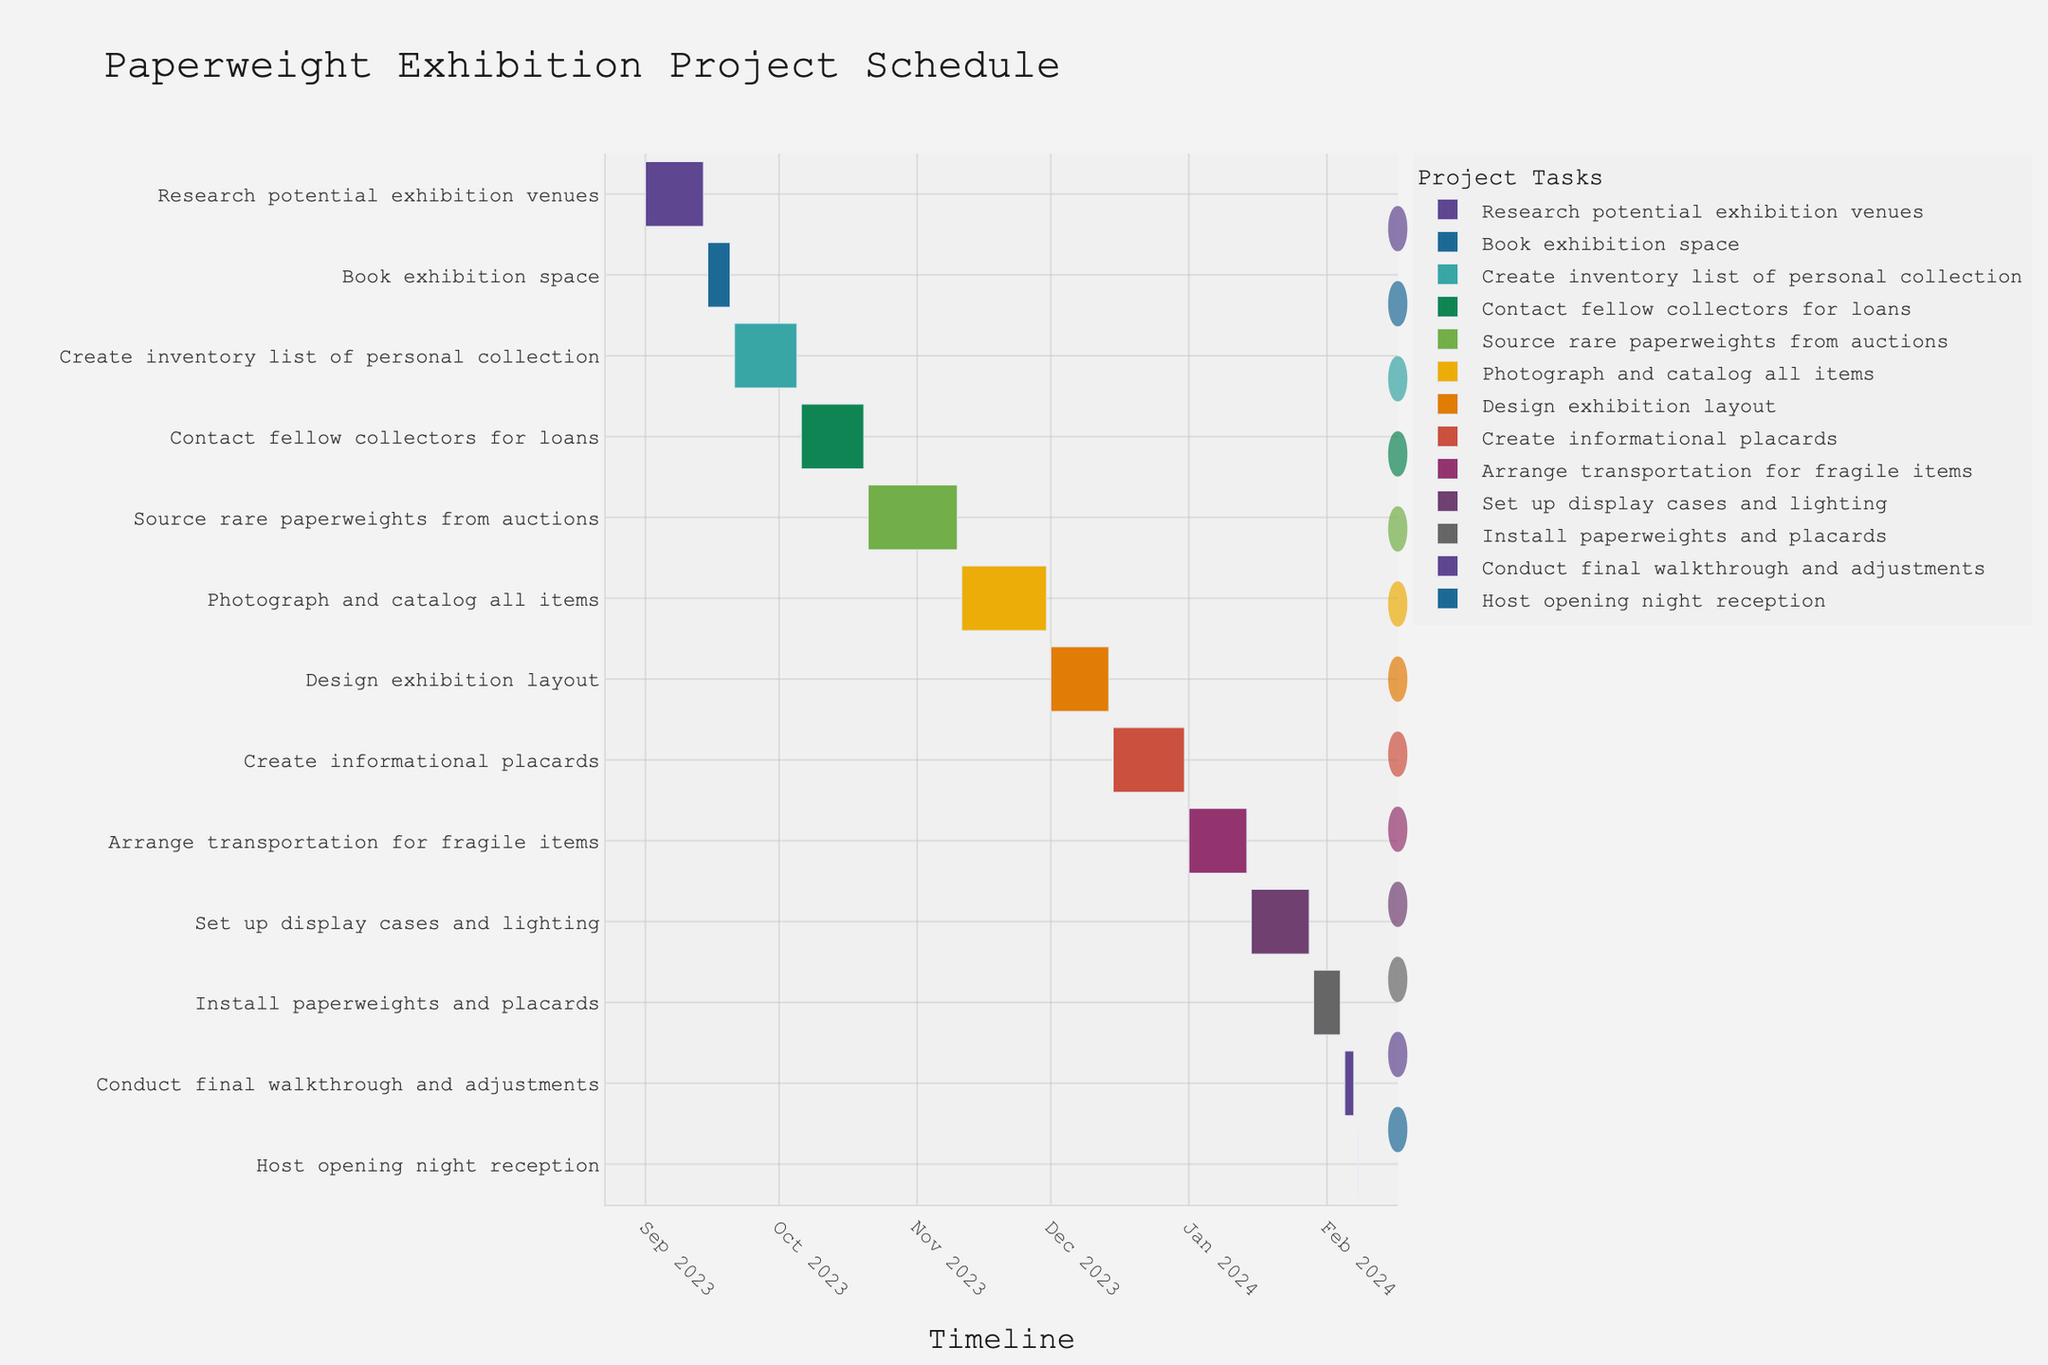What is the title of the Gantt chart? The title of the Gantt chart is visible at the top of the figure.
Answer: Paperweight Exhibition Project Schedule On which date does the task 'Set up display cases and lighting' start? The Gantt chart shows the start and end dates for each task on the timeline.
Answer: January 15, 2024 How many days are allocated for the task 'Contact fellow collectors for loans'? The end date for 'Contact fellow collectors for loans' is October 20, 2023, and the start date is October 6, 2023. The difference between these dates gives the task duration.
Answer: 14 days Arrange the tasks in chronological order starting from September 2023. By plotting the tasks against their start dates on the Gantt chart, we arrange them in chronological order starting from September 2023 to February 2024.
Answer: Research potential exhibition venues, Book exhibition space, Create inventory list of personal collection, Contact fellow collectors for loans, Source rare paperweights from auctions, Photograph and catalog all items, Design exhibition layout, Create informational placards, Arrange transportation for fragile items, Set up display cases and lighting, Install paperweights and placards, Conduct final walkthrough and adjustments, Host opening night reception Which task has the longest duration, and how long is it? From the Gantt chart, we can visually compare the length of each task bar to identify the longest one. Calculate duration for confirmation.
Answer: Create inventory list of personal collection, 15 days What tasks are scheduled to finish in December 2023? By examining the end dates on the Gantt chart, we identify tasks that end in December 2023.
Answer: Design exhibition layout, Create informational placards Which tasks overlap with the 'Photograph and catalog all items' task? Look at the timeline and identify tasks whose duration bars intersect with 'Photograph and catalog all items.'
Answer: Source rare paperweights from auctions, Design exhibition layout What is the total duration from the start of 'Research potential exhibition venues' to the end of 'Host opening night reception'? Calculate the time span from the start date of the first task to the end date of the last task.
Answer: 161 days What are the last two tasks before the opening night reception? From the Gantt chart, identify the last tasks scheduled before 'Host opening night reception.'
Answer: Install paperweights and placards, Conduct final walkthrough and adjustments 